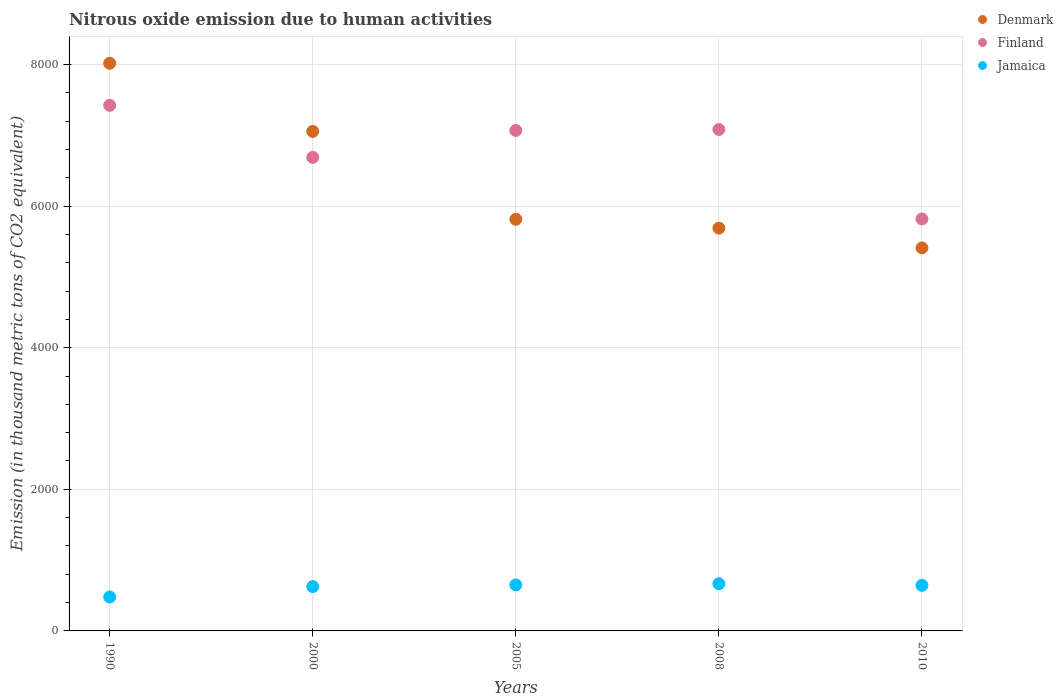Is the number of dotlines equal to the number of legend labels?
Your answer should be compact. Yes. What is the amount of nitrous oxide emitted in Finland in 2005?
Your answer should be compact. 7068. Across all years, what is the maximum amount of nitrous oxide emitted in Jamaica?
Keep it short and to the point. 666.6. Across all years, what is the minimum amount of nitrous oxide emitted in Jamaica?
Offer a terse response. 479.2. In which year was the amount of nitrous oxide emitted in Finland minimum?
Your answer should be very brief. 2010. What is the total amount of nitrous oxide emitted in Denmark in the graph?
Your answer should be very brief. 3.20e+04. What is the difference between the amount of nitrous oxide emitted in Finland in 2005 and that in 2008?
Your answer should be compact. -13.9. What is the difference between the amount of nitrous oxide emitted in Jamaica in 1990 and the amount of nitrous oxide emitted in Finland in 2008?
Ensure brevity in your answer.  -6602.7. What is the average amount of nitrous oxide emitted in Denmark per year?
Provide a short and direct response. 6396.88. In the year 2008, what is the difference between the amount of nitrous oxide emitted in Finland and amount of nitrous oxide emitted in Jamaica?
Give a very brief answer. 6415.3. In how many years, is the amount of nitrous oxide emitted in Jamaica greater than 2400 thousand metric tons?
Ensure brevity in your answer.  0. What is the ratio of the amount of nitrous oxide emitted in Denmark in 2005 to that in 2010?
Offer a terse response. 1.07. Is the amount of nitrous oxide emitted in Finland in 1990 less than that in 2000?
Ensure brevity in your answer.  No. What is the difference between the highest and the second highest amount of nitrous oxide emitted in Finland?
Offer a terse response. 341.1. What is the difference between the highest and the lowest amount of nitrous oxide emitted in Finland?
Your answer should be compact. 1604.6. Is the sum of the amount of nitrous oxide emitted in Denmark in 1990 and 2008 greater than the maximum amount of nitrous oxide emitted in Jamaica across all years?
Make the answer very short. Yes. Is the amount of nitrous oxide emitted in Finland strictly greater than the amount of nitrous oxide emitted in Jamaica over the years?
Offer a very short reply. Yes. How many legend labels are there?
Provide a short and direct response. 3. How are the legend labels stacked?
Provide a succinct answer. Vertical. What is the title of the graph?
Your answer should be compact. Nitrous oxide emission due to human activities. Does "United Kingdom" appear as one of the legend labels in the graph?
Your response must be concise. No. What is the label or title of the X-axis?
Provide a succinct answer. Years. What is the label or title of the Y-axis?
Offer a very short reply. Emission (in thousand metric tons of CO2 equivalent). What is the Emission (in thousand metric tons of CO2 equivalent) in Denmark in 1990?
Keep it short and to the point. 8017.4. What is the Emission (in thousand metric tons of CO2 equivalent) of Finland in 1990?
Provide a short and direct response. 7423. What is the Emission (in thousand metric tons of CO2 equivalent) in Jamaica in 1990?
Provide a short and direct response. 479.2. What is the Emission (in thousand metric tons of CO2 equivalent) in Denmark in 2000?
Offer a terse response. 7054.9. What is the Emission (in thousand metric tons of CO2 equivalent) of Finland in 2000?
Make the answer very short. 6688.1. What is the Emission (in thousand metric tons of CO2 equivalent) in Jamaica in 2000?
Your response must be concise. 626.2. What is the Emission (in thousand metric tons of CO2 equivalent) in Denmark in 2005?
Your answer should be very brief. 5813.9. What is the Emission (in thousand metric tons of CO2 equivalent) in Finland in 2005?
Offer a very short reply. 7068. What is the Emission (in thousand metric tons of CO2 equivalent) in Jamaica in 2005?
Offer a very short reply. 650.5. What is the Emission (in thousand metric tons of CO2 equivalent) of Denmark in 2008?
Give a very brief answer. 5688.2. What is the Emission (in thousand metric tons of CO2 equivalent) of Finland in 2008?
Your answer should be very brief. 7081.9. What is the Emission (in thousand metric tons of CO2 equivalent) in Jamaica in 2008?
Offer a terse response. 666.6. What is the Emission (in thousand metric tons of CO2 equivalent) of Denmark in 2010?
Keep it short and to the point. 5410. What is the Emission (in thousand metric tons of CO2 equivalent) in Finland in 2010?
Your answer should be very brief. 5818.4. What is the Emission (in thousand metric tons of CO2 equivalent) of Jamaica in 2010?
Provide a short and direct response. 643.3. Across all years, what is the maximum Emission (in thousand metric tons of CO2 equivalent) of Denmark?
Your answer should be very brief. 8017.4. Across all years, what is the maximum Emission (in thousand metric tons of CO2 equivalent) in Finland?
Your response must be concise. 7423. Across all years, what is the maximum Emission (in thousand metric tons of CO2 equivalent) in Jamaica?
Offer a very short reply. 666.6. Across all years, what is the minimum Emission (in thousand metric tons of CO2 equivalent) of Denmark?
Provide a succinct answer. 5410. Across all years, what is the minimum Emission (in thousand metric tons of CO2 equivalent) in Finland?
Provide a succinct answer. 5818.4. Across all years, what is the minimum Emission (in thousand metric tons of CO2 equivalent) in Jamaica?
Your answer should be very brief. 479.2. What is the total Emission (in thousand metric tons of CO2 equivalent) of Denmark in the graph?
Your answer should be very brief. 3.20e+04. What is the total Emission (in thousand metric tons of CO2 equivalent) of Finland in the graph?
Give a very brief answer. 3.41e+04. What is the total Emission (in thousand metric tons of CO2 equivalent) in Jamaica in the graph?
Make the answer very short. 3065.8. What is the difference between the Emission (in thousand metric tons of CO2 equivalent) in Denmark in 1990 and that in 2000?
Your response must be concise. 962.5. What is the difference between the Emission (in thousand metric tons of CO2 equivalent) of Finland in 1990 and that in 2000?
Your response must be concise. 734.9. What is the difference between the Emission (in thousand metric tons of CO2 equivalent) in Jamaica in 1990 and that in 2000?
Offer a terse response. -147. What is the difference between the Emission (in thousand metric tons of CO2 equivalent) in Denmark in 1990 and that in 2005?
Offer a very short reply. 2203.5. What is the difference between the Emission (in thousand metric tons of CO2 equivalent) of Finland in 1990 and that in 2005?
Your response must be concise. 355. What is the difference between the Emission (in thousand metric tons of CO2 equivalent) in Jamaica in 1990 and that in 2005?
Give a very brief answer. -171.3. What is the difference between the Emission (in thousand metric tons of CO2 equivalent) of Denmark in 1990 and that in 2008?
Make the answer very short. 2329.2. What is the difference between the Emission (in thousand metric tons of CO2 equivalent) in Finland in 1990 and that in 2008?
Offer a very short reply. 341.1. What is the difference between the Emission (in thousand metric tons of CO2 equivalent) of Jamaica in 1990 and that in 2008?
Make the answer very short. -187.4. What is the difference between the Emission (in thousand metric tons of CO2 equivalent) of Denmark in 1990 and that in 2010?
Make the answer very short. 2607.4. What is the difference between the Emission (in thousand metric tons of CO2 equivalent) in Finland in 1990 and that in 2010?
Give a very brief answer. 1604.6. What is the difference between the Emission (in thousand metric tons of CO2 equivalent) in Jamaica in 1990 and that in 2010?
Provide a short and direct response. -164.1. What is the difference between the Emission (in thousand metric tons of CO2 equivalent) in Denmark in 2000 and that in 2005?
Your answer should be compact. 1241. What is the difference between the Emission (in thousand metric tons of CO2 equivalent) in Finland in 2000 and that in 2005?
Your answer should be very brief. -379.9. What is the difference between the Emission (in thousand metric tons of CO2 equivalent) of Jamaica in 2000 and that in 2005?
Provide a succinct answer. -24.3. What is the difference between the Emission (in thousand metric tons of CO2 equivalent) of Denmark in 2000 and that in 2008?
Make the answer very short. 1366.7. What is the difference between the Emission (in thousand metric tons of CO2 equivalent) in Finland in 2000 and that in 2008?
Offer a terse response. -393.8. What is the difference between the Emission (in thousand metric tons of CO2 equivalent) in Jamaica in 2000 and that in 2008?
Your answer should be compact. -40.4. What is the difference between the Emission (in thousand metric tons of CO2 equivalent) of Denmark in 2000 and that in 2010?
Make the answer very short. 1644.9. What is the difference between the Emission (in thousand metric tons of CO2 equivalent) of Finland in 2000 and that in 2010?
Give a very brief answer. 869.7. What is the difference between the Emission (in thousand metric tons of CO2 equivalent) in Jamaica in 2000 and that in 2010?
Ensure brevity in your answer.  -17.1. What is the difference between the Emission (in thousand metric tons of CO2 equivalent) in Denmark in 2005 and that in 2008?
Provide a succinct answer. 125.7. What is the difference between the Emission (in thousand metric tons of CO2 equivalent) of Jamaica in 2005 and that in 2008?
Your response must be concise. -16.1. What is the difference between the Emission (in thousand metric tons of CO2 equivalent) of Denmark in 2005 and that in 2010?
Keep it short and to the point. 403.9. What is the difference between the Emission (in thousand metric tons of CO2 equivalent) in Finland in 2005 and that in 2010?
Your answer should be compact. 1249.6. What is the difference between the Emission (in thousand metric tons of CO2 equivalent) in Jamaica in 2005 and that in 2010?
Keep it short and to the point. 7.2. What is the difference between the Emission (in thousand metric tons of CO2 equivalent) of Denmark in 2008 and that in 2010?
Give a very brief answer. 278.2. What is the difference between the Emission (in thousand metric tons of CO2 equivalent) of Finland in 2008 and that in 2010?
Give a very brief answer. 1263.5. What is the difference between the Emission (in thousand metric tons of CO2 equivalent) in Jamaica in 2008 and that in 2010?
Offer a terse response. 23.3. What is the difference between the Emission (in thousand metric tons of CO2 equivalent) in Denmark in 1990 and the Emission (in thousand metric tons of CO2 equivalent) in Finland in 2000?
Provide a short and direct response. 1329.3. What is the difference between the Emission (in thousand metric tons of CO2 equivalent) in Denmark in 1990 and the Emission (in thousand metric tons of CO2 equivalent) in Jamaica in 2000?
Your response must be concise. 7391.2. What is the difference between the Emission (in thousand metric tons of CO2 equivalent) in Finland in 1990 and the Emission (in thousand metric tons of CO2 equivalent) in Jamaica in 2000?
Offer a terse response. 6796.8. What is the difference between the Emission (in thousand metric tons of CO2 equivalent) in Denmark in 1990 and the Emission (in thousand metric tons of CO2 equivalent) in Finland in 2005?
Give a very brief answer. 949.4. What is the difference between the Emission (in thousand metric tons of CO2 equivalent) of Denmark in 1990 and the Emission (in thousand metric tons of CO2 equivalent) of Jamaica in 2005?
Your answer should be very brief. 7366.9. What is the difference between the Emission (in thousand metric tons of CO2 equivalent) in Finland in 1990 and the Emission (in thousand metric tons of CO2 equivalent) in Jamaica in 2005?
Ensure brevity in your answer.  6772.5. What is the difference between the Emission (in thousand metric tons of CO2 equivalent) in Denmark in 1990 and the Emission (in thousand metric tons of CO2 equivalent) in Finland in 2008?
Ensure brevity in your answer.  935.5. What is the difference between the Emission (in thousand metric tons of CO2 equivalent) in Denmark in 1990 and the Emission (in thousand metric tons of CO2 equivalent) in Jamaica in 2008?
Offer a terse response. 7350.8. What is the difference between the Emission (in thousand metric tons of CO2 equivalent) in Finland in 1990 and the Emission (in thousand metric tons of CO2 equivalent) in Jamaica in 2008?
Provide a short and direct response. 6756.4. What is the difference between the Emission (in thousand metric tons of CO2 equivalent) in Denmark in 1990 and the Emission (in thousand metric tons of CO2 equivalent) in Finland in 2010?
Provide a succinct answer. 2199. What is the difference between the Emission (in thousand metric tons of CO2 equivalent) of Denmark in 1990 and the Emission (in thousand metric tons of CO2 equivalent) of Jamaica in 2010?
Your answer should be compact. 7374.1. What is the difference between the Emission (in thousand metric tons of CO2 equivalent) in Finland in 1990 and the Emission (in thousand metric tons of CO2 equivalent) in Jamaica in 2010?
Offer a very short reply. 6779.7. What is the difference between the Emission (in thousand metric tons of CO2 equivalent) of Denmark in 2000 and the Emission (in thousand metric tons of CO2 equivalent) of Jamaica in 2005?
Offer a very short reply. 6404.4. What is the difference between the Emission (in thousand metric tons of CO2 equivalent) in Finland in 2000 and the Emission (in thousand metric tons of CO2 equivalent) in Jamaica in 2005?
Your answer should be compact. 6037.6. What is the difference between the Emission (in thousand metric tons of CO2 equivalent) of Denmark in 2000 and the Emission (in thousand metric tons of CO2 equivalent) of Finland in 2008?
Offer a terse response. -27. What is the difference between the Emission (in thousand metric tons of CO2 equivalent) of Denmark in 2000 and the Emission (in thousand metric tons of CO2 equivalent) of Jamaica in 2008?
Offer a very short reply. 6388.3. What is the difference between the Emission (in thousand metric tons of CO2 equivalent) of Finland in 2000 and the Emission (in thousand metric tons of CO2 equivalent) of Jamaica in 2008?
Give a very brief answer. 6021.5. What is the difference between the Emission (in thousand metric tons of CO2 equivalent) in Denmark in 2000 and the Emission (in thousand metric tons of CO2 equivalent) in Finland in 2010?
Offer a very short reply. 1236.5. What is the difference between the Emission (in thousand metric tons of CO2 equivalent) in Denmark in 2000 and the Emission (in thousand metric tons of CO2 equivalent) in Jamaica in 2010?
Offer a terse response. 6411.6. What is the difference between the Emission (in thousand metric tons of CO2 equivalent) of Finland in 2000 and the Emission (in thousand metric tons of CO2 equivalent) of Jamaica in 2010?
Offer a terse response. 6044.8. What is the difference between the Emission (in thousand metric tons of CO2 equivalent) in Denmark in 2005 and the Emission (in thousand metric tons of CO2 equivalent) in Finland in 2008?
Your answer should be very brief. -1268. What is the difference between the Emission (in thousand metric tons of CO2 equivalent) of Denmark in 2005 and the Emission (in thousand metric tons of CO2 equivalent) of Jamaica in 2008?
Make the answer very short. 5147.3. What is the difference between the Emission (in thousand metric tons of CO2 equivalent) of Finland in 2005 and the Emission (in thousand metric tons of CO2 equivalent) of Jamaica in 2008?
Your response must be concise. 6401.4. What is the difference between the Emission (in thousand metric tons of CO2 equivalent) in Denmark in 2005 and the Emission (in thousand metric tons of CO2 equivalent) in Finland in 2010?
Make the answer very short. -4.5. What is the difference between the Emission (in thousand metric tons of CO2 equivalent) in Denmark in 2005 and the Emission (in thousand metric tons of CO2 equivalent) in Jamaica in 2010?
Give a very brief answer. 5170.6. What is the difference between the Emission (in thousand metric tons of CO2 equivalent) in Finland in 2005 and the Emission (in thousand metric tons of CO2 equivalent) in Jamaica in 2010?
Keep it short and to the point. 6424.7. What is the difference between the Emission (in thousand metric tons of CO2 equivalent) in Denmark in 2008 and the Emission (in thousand metric tons of CO2 equivalent) in Finland in 2010?
Give a very brief answer. -130.2. What is the difference between the Emission (in thousand metric tons of CO2 equivalent) of Denmark in 2008 and the Emission (in thousand metric tons of CO2 equivalent) of Jamaica in 2010?
Provide a succinct answer. 5044.9. What is the difference between the Emission (in thousand metric tons of CO2 equivalent) in Finland in 2008 and the Emission (in thousand metric tons of CO2 equivalent) in Jamaica in 2010?
Provide a succinct answer. 6438.6. What is the average Emission (in thousand metric tons of CO2 equivalent) of Denmark per year?
Give a very brief answer. 6396.88. What is the average Emission (in thousand metric tons of CO2 equivalent) of Finland per year?
Make the answer very short. 6815.88. What is the average Emission (in thousand metric tons of CO2 equivalent) of Jamaica per year?
Your answer should be compact. 613.16. In the year 1990, what is the difference between the Emission (in thousand metric tons of CO2 equivalent) in Denmark and Emission (in thousand metric tons of CO2 equivalent) in Finland?
Offer a very short reply. 594.4. In the year 1990, what is the difference between the Emission (in thousand metric tons of CO2 equivalent) in Denmark and Emission (in thousand metric tons of CO2 equivalent) in Jamaica?
Your answer should be compact. 7538.2. In the year 1990, what is the difference between the Emission (in thousand metric tons of CO2 equivalent) in Finland and Emission (in thousand metric tons of CO2 equivalent) in Jamaica?
Your answer should be very brief. 6943.8. In the year 2000, what is the difference between the Emission (in thousand metric tons of CO2 equivalent) of Denmark and Emission (in thousand metric tons of CO2 equivalent) of Finland?
Keep it short and to the point. 366.8. In the year 2000, what is the difference between the Emission (in thousand metric tons of CO2 equivalent) of Denmark and Emission (in thousand metric tons of CO2 equivalent) of Jamaica?
Keep it short and to the point. 6428.7. In the year 2000, what is the difference between the Emission (in thousand metric tons of CO2 equivalent) of Finland and Emission (in thousand metric tons of CO2 equivalent) of Jamaica?
Your answer should be very brief. 6061.9. In the year 2005, what is the difference between the Emission (in thousand metric tons of CO2 equivalent) in Denmark and Emission (in thousand metric tons of CO2 equivalent) in Finland?
Your answer should be very brief. -1254.1. In the year 2005, what is the difference between the Emission (in thousand metric tons of CO2 equivalent) of Denmark and Emission (in thousand metric tons of CO2 equivalent) of Jamaica?
Provide a short and direct response. 5163.4. In the year 2005, what is the difference between the Emission (in thousand metric tons of CO2 equivalent) in Finland and Emission (in thousand metric tons of CO2 equivalent) in Jamaica?
Offer a very short reply. 6417.5. In the year 2008, what is the difference between the Emission (in thousand metric tons of CO2 equivalent) of Denmark and Emission (in thousand metric tons of CO2 equivalent) of Finland?
Offer a terse response. -1393.7. In the year 2008, what is the difference between the Emission (in thousand metric tons of CO2 equivalent) of Denmark and Emission (in thousand metric tons of CO2 equivalent) of Jamaica?
Your answer should be very brief. 5021.6. In the year 2008, what is the difference between the Emission (in thousand metric tons of CO2 equivalent) in Finland and Emission (in thousand metric tons of CO2 equivalent) in Jamaica?
Provide a short and direct response. 6415.3. In the year 2010, what is the difference between the Emission (in thousand metric tons of CO2 equivalent) in Denmark and Emission (in thousand metric tons of CO2 equivalent) in Finland?
Your answer should be very brief. -408.4. In the year 2010, what is the difference between the Emission (in thousand metric tons of CO2 equivalent) in Denmark and Emission (in thousand metric tons of CO2 equivalent) in Jamaica?
Offer a terse response. 4766.7. In the year 2010, what is the difference between the Emission (in thousand metric tons of CO2 equivalent) of Finland and Emission (in thousand metric tons of CO2 equivalent) of Jamaica?
Provide a succinct answer. 5175.1. What is the ratio of the Emission (in thousand metric tons of CO2 equivalent) in Denmark in 1990 to that in 2000?
Give a very brief answer. 1.14. What is the ratio of the Emission (in thousand metric tons of CO2 equivalent) in Finland in 1990 to that in 2000?
Provide a succinct answer. 1.11. What is the ratio of the Emission (in thousand metric tons of CO2 equivalent) of Jamaica in 1990 to that in 2000?
Make the answer very short. 0.77. What is the ratio of the Emission (in thousand metric tons of CO2 equivalent) in Denmark in 1990 to that in 2005?
Your answer should be very brief. 1.38. What is the ratio of the Emission (in thousand metric tons of CO2 equivalent) of Finland in 1990 to that in 2005?
Your response must be concise. 1.05. What is the ratio of the Emission (in thousand metric tons of CO2 equivalent) of Jamaica in 1990 to that in 2005?
Ensure brevity in your answer.  0.74. What is the ratio of the Emission (in thousand metric tons of CO2 equivalent) of Denmark in 1990 to that in 2008?
Ensure brevity in your answer.  1.41. What is the ratio of the Emission (in thousand metric tons of CO2 equivalent) in Finland in 1990 to that in 2008?
Provide a succinct answer. 1.05. What is the ratio of the Emission (in thousand metric tons of CO2 equivalent) in Jamaica in 1990 to that in 2008?
Provide a short and direct response. 0.72. What is the ratio of the Emission (in thousand metric tons of CO2 equivalent) in Denmark in 1990 to that in 2010?
Offer a terse response. 1.48. What is the ratio of the Emission (in thousand metric tons of CO2 equivalent) in Finland in 1990 to that in 2010?
Ensure brevity in your answer.  1.28. What is the ratio of the Emission (in thousand metric tons of CO2 equivalent) in Jamaica in 1990 to that in 2010?
Provide a short and direct response. 0.74. What is the ratio of the Emission (in thousand metric tons of CO2 equivalent) in Denmark in 2000 to that in 2005?
Your answer should be very brief. 1.21. What is the ratio of the Emission (in thousand metric tons of CO2 equivalent) in Finland in 2000 to that in 2005?
Ensure brevity in your answer.  0.95. What is the ratio of the Emission (in thousand metric tons of CO2 equivalent) in Jamaica in 2000 to that in 2005?
Give a very brief answer. 0.96. What is the ratio of the Emission (in thousand metric tons of CO2 equivalent) in Denmark in 2000 to that in 2008?
Provide a short and direct response. 1.24. What is the ratio of the Emission (in thousand metric tons of CO2 equivalent) of Jamaica in 2000 to that in 2008?
Your answer should be very brief. 0.94. What is the ratio of the Emission (in thousand metric tons of CO2 equivalent) in Denmark in 2000 to that in 2010?
Ensure brevity in your answer.  1.3. What is the ratio of the Emission (in thousand metric tons of CO2 equivalent) of Finland in 2000 to that in 2010?
Provide a short and direct response. 1.15. What is the ratio of the Emission (in thousand metric tons of CO2 equivalent) in Jamaica in 2000 to that in 2010?
Give a very brief answer. 0.97. What is the ratio of the Emission (in thousand metric tons of CO2 equivalent) of Denmark in 2005 to that in 2008?
Provide a succinct answer. 1.02. What is the ratio of the Emission (in thousand metric tons of CO2 equivalent) in Finland in 2005 to that in 2008?
Make the answer very short. 1. What is the ratio of the Emission (in thousand metric tons of CO2 equivalent) in Jamaica in 2005 to that in 2008?
Make the answer very short. 0.98. What is the ratio of the Emission (in thousand metric tons of CO2 equivalent) of Denmark in 2005 to that in 2010?
Give a very brief answer. 1.07. What is the ratio of the Emission (in thousand metric tons of CO2 equivalent) of Finland in 2005 to that in 2010?
Give a very brief answer. 1.21. What is the ratio of the Emission (in thousand metric tons of CO2 equivalent) of Jamaica in 2005 to that in 2010?
Your answer should be very brief. 1.01. What is the ratio of the Emission (in thousand metric tons of CO2 equivalent) in Denmark in 2008 to that in 2010?
Your response must be concise. 1.05. What is the ratio of the Emission (in thousand metric tons of CO2 equivalent) of Finland in 2008 to that in 2010?
Make the answer very short. 1.22. What is the ratio of the Emission (in thousand metric tons of CO2 equivalent) of Jamaica in 2008 to that in 2010?
Give a very brief answer. 1.04. What is the difference between the highest and the second highest Emission (in thousand metric tons of CO2 equivalent) of Denmark?
Provide a succinct answer. 962.5. What is the difference between the highest and the second highest Emission (in thousand metric tons of CO2 equivalent) of Finland?
Provide a succinct answer. 341.1. What is the difference between the highest and the second highest Emission (in thousand metric tons of CO2 equivalent) of Jamaica?
Make the answer very short. 16.1. What is the difference between the highest and the lowest Emission (in thousand metric tons of CO2 equivalent) in Denmark?
Offer a very short reply. 2607.4. What is the difference between the highest and the lowest Emission (in thousand metric tons of CO2 equivalent) in Finland?
Provide a short and direct response. 1604.6. What is the difference between the highest and the lowest Emission (in thousand metric tons of CO2 equivalent) in Jamaica?
Make the answer very short. 187.4. 